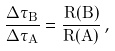Convert formula to latex. <formula><loc_0><loc_0><loc_500><loc_500>\frac { \Delta \tau _ { B } } { \Delta \tau _ { A } } = \frac { R ( B ) } { R ( A ) } \, ,</formula> 